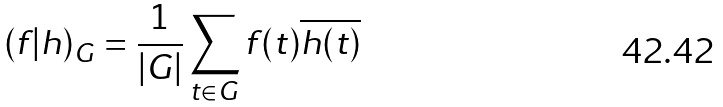Convert formula to latex. <formula><loc_0><loc_0><loc_500><loc_500>( f | h ) _ { G } = { \frac { 1 } { | G | } } \sum _ { t \in G } f ( t ) { \overline { h ( t ) } }</formula> 